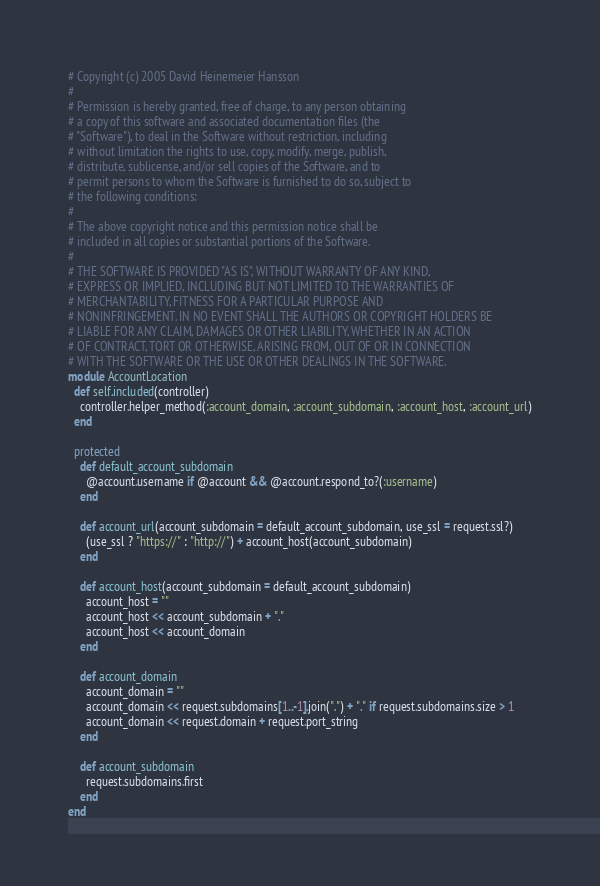<code> <loc_0><loc_0><loc_500><loc_500><_Ruby_># Copyright (c) 2005 David Heinemeier Hansson
#
# Permission is hereby granted, free of charge, to any person obtaining
# a copy of this software and associated documentation files (the
# "Software"), to deal in the Software without restriction, including
# without limitation the rights to use, copy, modify, merge, publish,
# distribute, sublicense, and/or sell copies of the Software, and to
# permit persons to whom the Software is furnished to do so, subject to
# the following conditions:
#
# The above copyright notice and this permission notice shall be
# included in all copies or substantial portions of the Software.
#
# THE SOFTWARE IS PROVIDED "AS IS", WITHOUT WARRANTY OF ANY KIND,
# EXPRESS OR IMPLIED, INCLUDING BUT NOT LIMITED TO THE WARRANTIES OF
# MERCHANTABILITY, FITNESS FOR A PARTICULAR PURPOSE AND
# NONINFRINGEMENT. IN NO EVENT SHALL THE AUTHORS OR COPYRIGHT HOLDERS BE
# LIABLE FOR ANY CLAIM, DAMAGES OR OTHER LIABILITY, WHETHER IN AN ACTION
# OF CONTRACT, TORT OR OTHERWISE, ARISING FROM, OUT OF OR IN CONNECTION
# WITH THE SOFTWARE OR THE USE OR OTHER DEALINGS IN THE SOFTWARE.
module AccountLocation
  def self.included(controller)
    controller.helper_method(:account_domain, :account_subdomain, :account_host, :account_url)
  end

  protected
    def default_account_subdomain
      @account.username if @account && @account.respond_to?(:username)
    end
  
    def account_url(account_subdomain = default_account_subdomain, use_ssl = request.ssl?)
      (use_ssl ? "https://" : "http://") + account_host(account_subdomain)
    end

    def account_host(account_subdomain = default_account_subdomain)
      account_host = ""
      account_host << account_subdomain + "."
      account_host << account_domain
    end

    def account_domain
      account_domain = ""
      account_domain << request.subdomains[1..-1].join(".") + "." if request.subdomains.size > 1
      account_domain << request.domain + request.port_string
    end
    
    def account_subdomain
      request.subdomains.first
    end
end</code> 